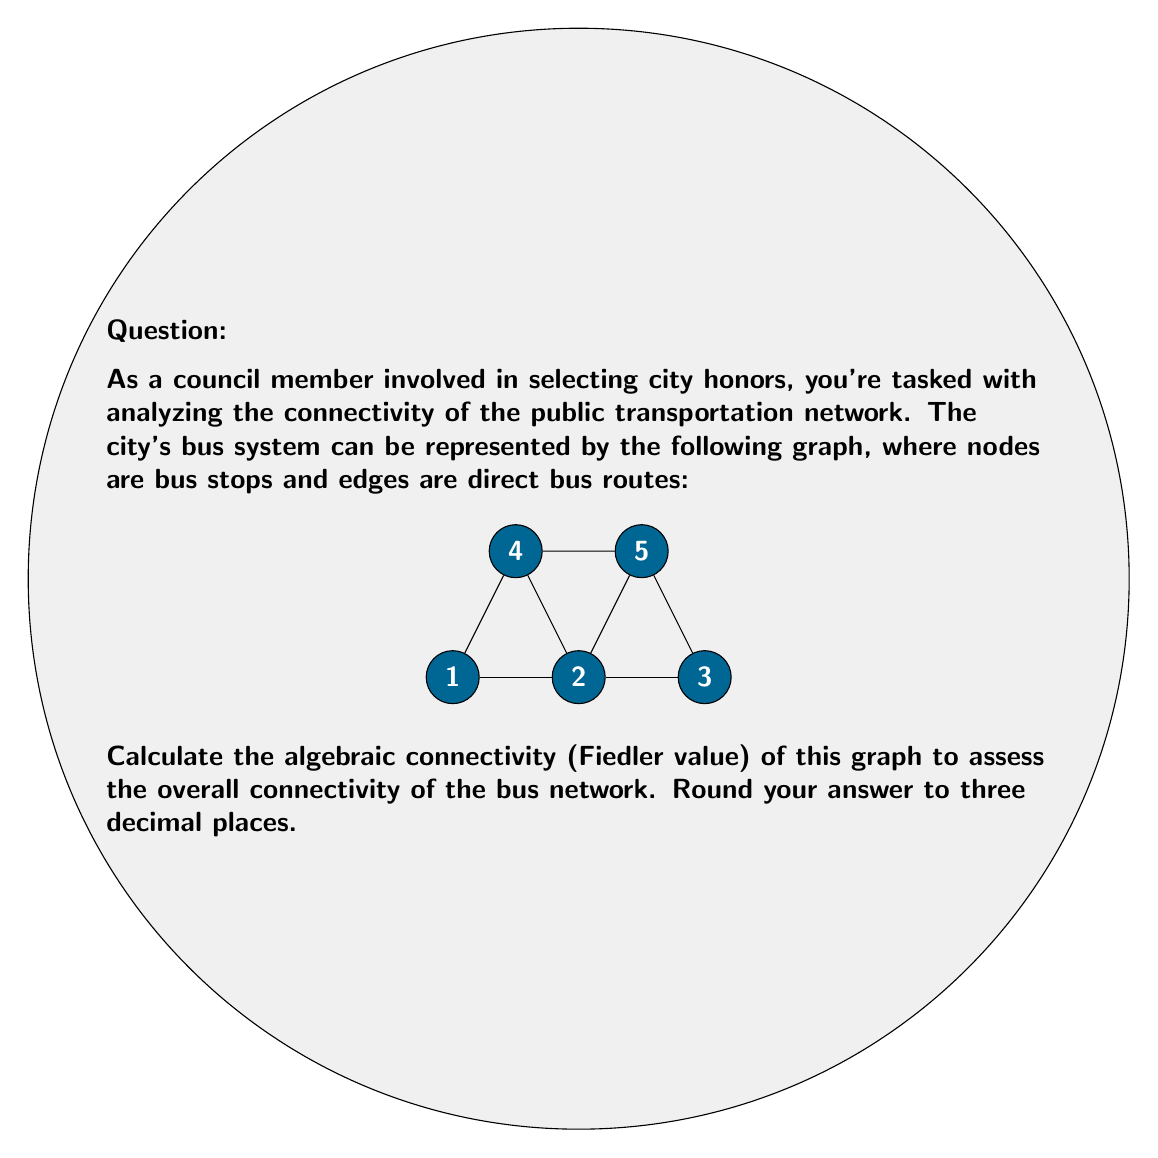Provide a solution to this math problem. To find the algebraic connectivity, we need to follow these steps:

1) First, construct the Laplacian matrix $L$ of the graph. For a graph with $n$ vertices, $L = D - A$, where $D$ is the degree matrix and $A$ is the adjacency matrix.

2) The degree matrix $D$ is:
   $$D = \begin{bmatrix}
   2 & 0 & 0 & 0 & 0 \\
   0 & 4 & 0 & 0 & 0 \\
   0 & 0 & 2 & 0 & 0 \\
   0 & 0 & 0 & 2 & 0 \\
   0 & 0 & 0 & 0 & 2
   \end{bmatrix}$$

3) The adjacency matrix $A$ is:
   $$A = \begin{bmatrix}
   0 & 1 & 0 & 1 & 0 \\
   1 & 0 & 0 & 1 & 1 \\
   0 & 0 & 0 & 0 & 1 \\
   1 & 1 & 0 & 0 & 0 \\
   0 & 1 & 1 & 0 & 0
   \end{bmatrix}$$

4) The Laplacian matrix $L = D - A$ is:
   $$L = \begin{bmatrix}
   2 & -1 & 0 & -1 & 0 \\
   -1 & 4 & 0 & -1 & -1 \\
   0 & 0 & 2 & 0 & -1 \\
   -1 & -1 & 0 & 2 & 0 \\
   0 & -1 & -1 & 0 & 2
   \end{bmatrix}$$

5) Calculate the eigenvalues of $L$. Using a computer algebra system or numerical methods, we find the eigenvalues are approximately:
   $0, 0.5858, 2.0000, 3.4142, 6.0000$

6) The algebraic connectivity (Fiedler value) is the second smallest eigenvalue, which is approximately 0.5858.

7) Rounding to three decimal places, we get 0.586.

This value indicates a moderate level of connectivity. A higher value would suggest better overall connectivity in the network.
Answer: 0.586 